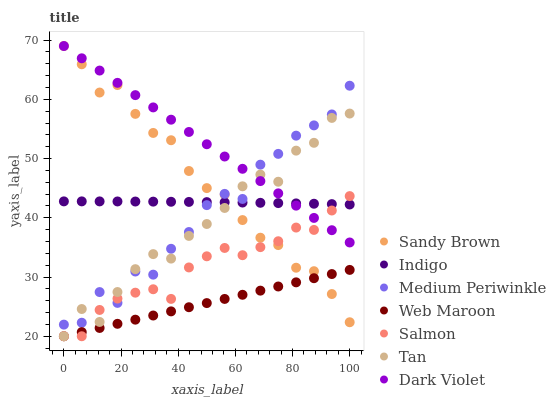Does Web Maroon have the minimum area under the curve?
Answer yes or no. Yes. Does Dark Violet have the maximum area under the curve?
Answer yes or no. Yes. Does Medium Periwinkle have the minimum area under the curve?
Answer yes or no. No. Does Medium Periwinkle have the maximum area under the curve?
Answer yes or no. No. Is Dark Violet the smoothest?
Answer yes or no. Yes. Is Medium Periwinkle the roughest?
Answer yes or no. Yes. Is Web Maroon the smoothest?
Answer yes or no. No. Is Web Maroon the roughest?
Answer yes or no. No. Does Web Maroon have the lowest value?
Answer yes or no. Yes. Does Medium Periwinkle have the lowest value?
Answer yes or no. No. Does Sandy Brown have the highest value?
Answer yes or no. Yes. Does Medium Periwinkle have the highest value?
Answer yes or no. No. Is Web Maroon less than Medium Periwinkle?
Answer yes or no. Yes. Is Medium Periwinkle greater than Web Maroon?
Answer yes or no. Yes. Does Salmon intersect Tan?
Answer yes or no. Yes. Is Salmon less than Tan?
Answer yes or no. No. Is Salmon greater than Tan?
Answer yes or no. No. Does Web Maroon intersect Medium Periwinkle?
Answer yes or no. No. 